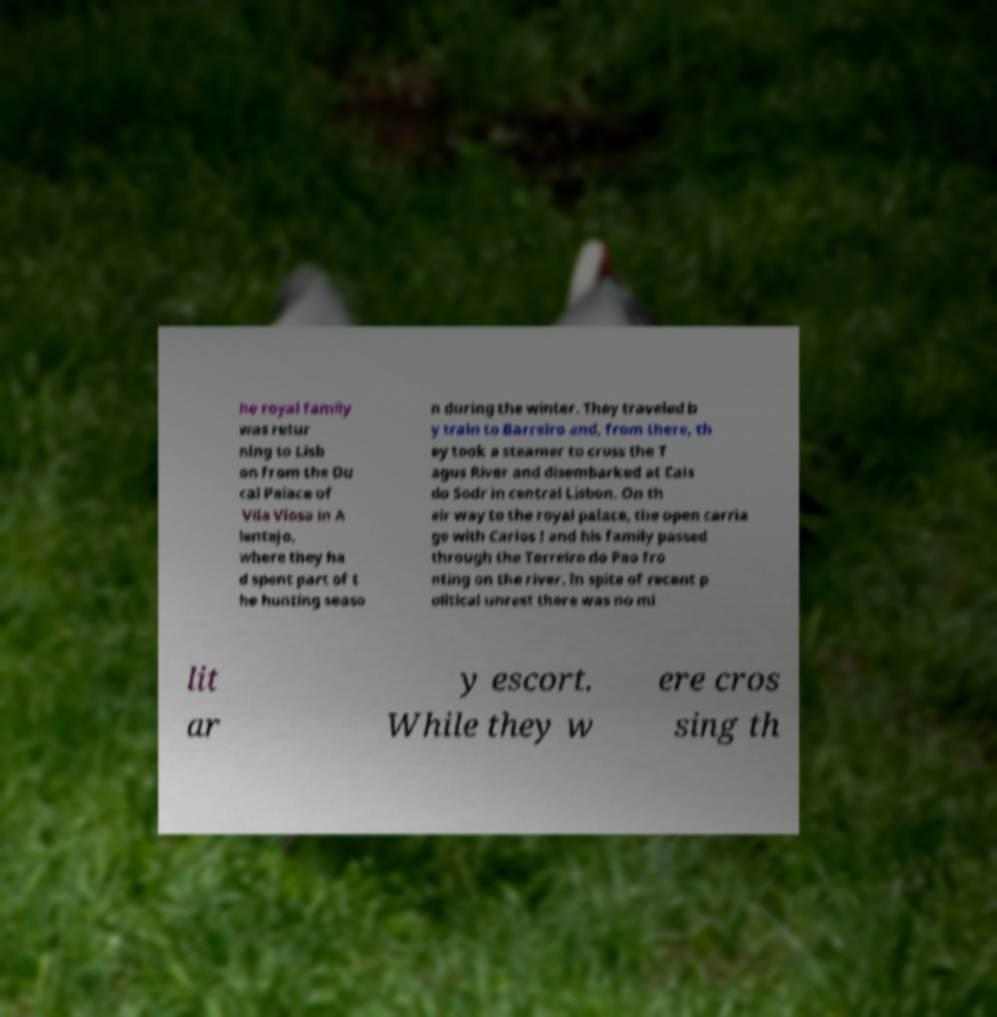Can you read and provide the text displayed in the image?This photo seems to have some interesting text. Can you extract and type it out for me? he royal family was retur ning to Lisb on from the Du cal Palace of Vila Viosa in A lentejo, where they ha d spent part of t he hunting seaso n during the winter. They traveled b y train to Barreiro and, from there, th ey took a steamer to cross the T agus River and disembarked at Cais do Sodr in central Lisbon. On th eir way to the royal palace, the open carria ge with Carlos I and his family passed through the Terreiro do Pao fro nting on the river. In spite of recent p olitical unrest there was no mi lit ar y escort. While they w ere cros sing th 